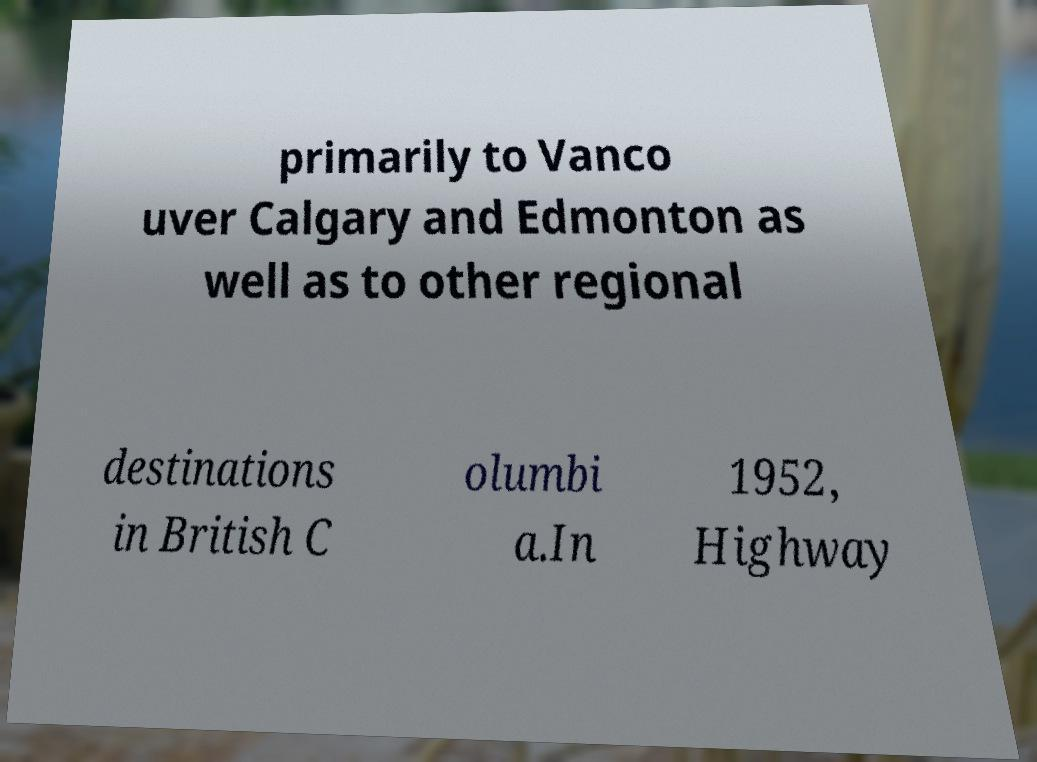Please read and relay the text visible in this image. What does it say? primarily to Vanco uver Calgary and Edmonton as well as to other regional destinations in British C olumbi a.In 1952, Highway 